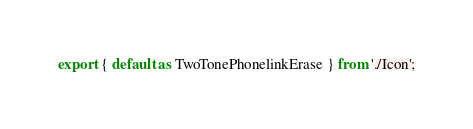Convert code to text. <code><loc_0><loc_0><loc_500><loc_500><_TypeScript_>export { default as TwoTonePhonelinkErase } from './Icon';
</code> 